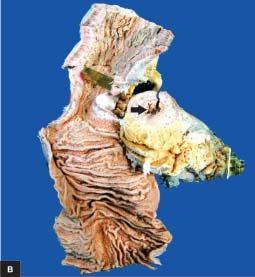does external surface show increased mesenteric fat, thickened wall and narrow lumen?
Answer the question using a single word or phrase. Yes 